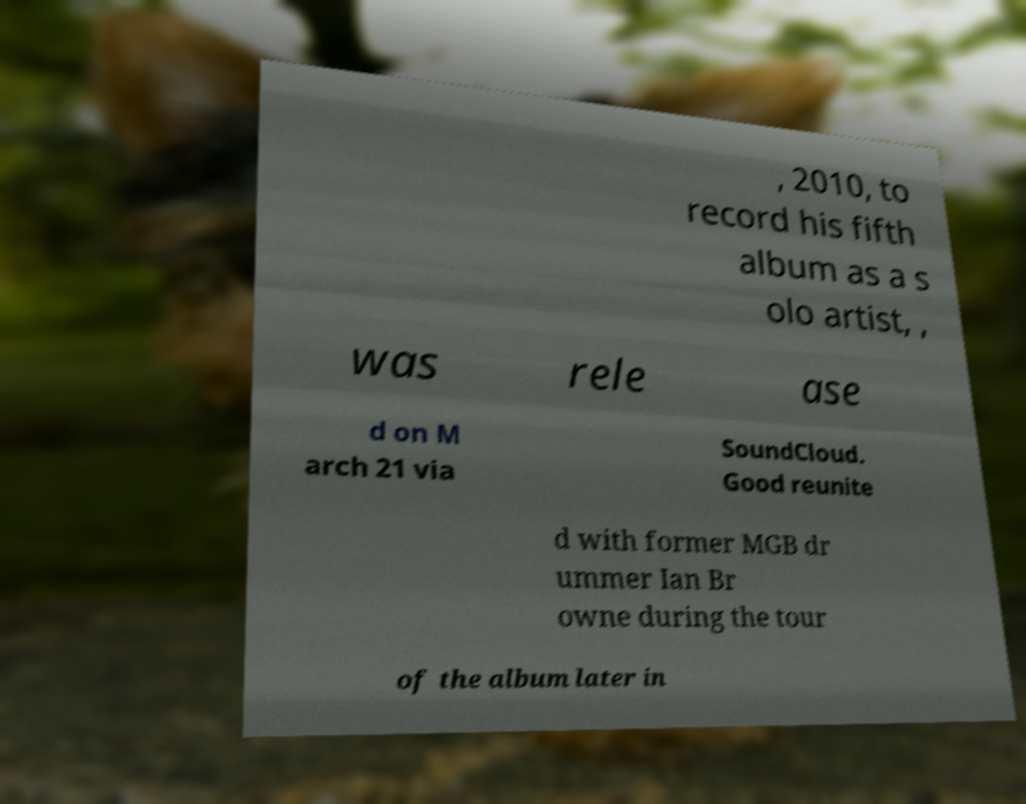I need the written content from this picture converted into text. Can you do that? , 2010, to record his fifth album as a s olo artist, , was rele ase d on M arch 21 via SoundCloud. Good reunite d with former MGB dr ummer Ian Br owne during the tour of the album later in 